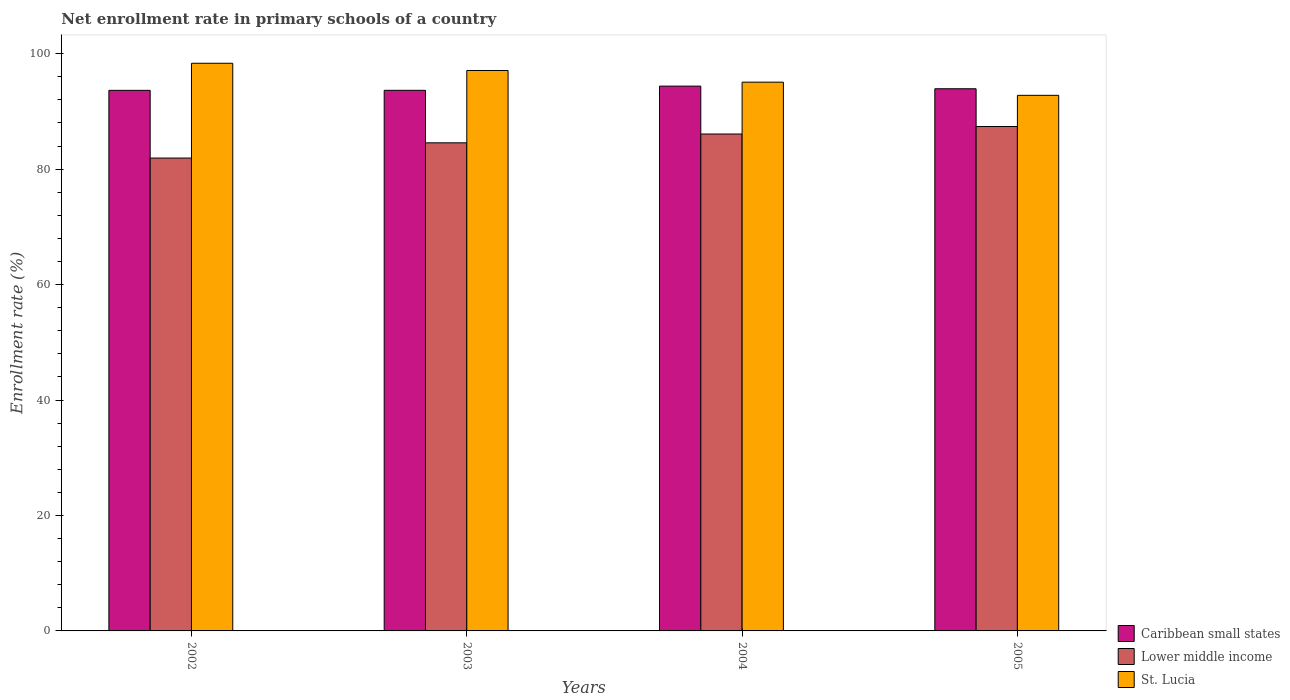Are the number of bars on each tick of the X-axis equal?
Provide a short and direct response. Yes. What is the label of the 1st group of bars from the left?
Ensure brevity in your answer.  2002. What is the enrollment rate in primary schools in St. Lucia in 2005?
Your response must be concise. 92.78. Across all years, what is the maximum enrollment rate in primary schools in Lower middle income?
Provide a short and direct response. 87.38. Across all years, what is the minimum enrollment rate in primary schools in St. Lucia?
Your answer should be very brief. 92.78. In which year was the enrollment rate in primary schools in Lower middle income maximum?
Your answer should be very brief. 2005. In which year was the enrollment rate in primary schools in Lower middle income minimum?
Offer a very short reply. 2002. What is the total enrollment rate in primary schools in Lower middle income in the graph?
Provide a short and direct response. 339.95. What is the difference between the enrollment rate in primary schools in Caribbean small states in 2003 and that in 2004?
Your response must be concise. -0.73. What is the difference between the enrollment rate in primary schools in Caribbean small states in 2005 and the enrollment rate in primary schools in St. Lucia in 2004?
Keep it short and to the point. -1.14. What is the average enrollment rate in primary schools in St. Lucia per year?
Ensure brevity in your answer.  95.82. In the year 2005, what is the difference between the enrollment rate in primary schools in Lower middle income and enrollment rate in primary schools in St. Lucia?
Make the answer very short. -5.4. In how many years, is the enrollment rate in primary schools in Lower middle income greater than 8 %?
Offer a very short reply. 4. What is the ratio of the enrollment rate in primary schools in Lower middle income in 2002 to that in 2003?
Offer a terse response. 0.97. Is the enrollment rate in primary schools in Caribbean small states in 2003 less than that in 2005?
Provide a succinct answer. Yes. What is the difference between the highest and the second highest enrollment rate in primary schools in Caribbean small states?
Provide a succinct answer. 0.46. What is the difference between the highest and the lowest enrollment rate in primary schools in Caribbean small states?
Provide a succinct answer. 0.73. What does the 3rd bar from the left in 2005 represents?
Keep it short and to the point. St. Lucia. What does the 3rd bar from the right in 2002 represents?
Offer a very short reply. Caribbean small states. Is it the case that in every year, the sum of the enrollment rate in primary schools in St. Lucia and enrollment rate in primary schools in Caribbean small states is greater than the enrollment rate in primary schools in Lower middle income?
Provide a succinct answer. Yes. Are all the bars in the graph horizontal?
Your answer should be compact. No. Where does the legend appear in the graph?
Ensure brevity in your answer.  Bottom right. How many legend labels are there?
Your answer should be very brief. 3. How are the legend labels stacked?
Your answer should be compact. Vertical. What is the title of the graph?
Ensure brevity in your answer.  Net enrollment rate in primary schools of a country. What is the label or title of the Y-axis?
Ensure brevity in your answer.  Enrollment rate (%). What is the Enrollment rate (%) in Caribbean small states in 2002?
Your answer should be very brief. 93.65. What is the Enrollment rate (%) of Lower middle income in 2002?
Provide a short and direct response. 81.92. What is the Enrollment rate (%) in St. Lucia in 2002?
Offer a very short reply. 98.34. What is the Enrollment rate (%) in Caribbean small states in 2003?
Offer a terse response. 93.65. What is the Enrollment rate (%) in Lower middle income in 2003?
Provide a succinct answer. 84.56. What is the Enrollment rate (%) in St. Lucia in 2003?
Offer a terse response. 97.09. What is the Enrollment rate (%) of Caribbean small states in 2004?
Offer a terse response. 94.38. What is the Enrollment rate (%) of Lower middle income in 2004?
Offer a terse response. 86.09. What is the Enrollment rate (%) in St. Lucia in 2004?
Keep it short and to the point. 95.07. What is the Enrollment rate (%) of Caribbean small states in 2005?
Make the answer very short. 93.93. What is the Enrollment rate (%) of Lower middle income in 2005?
Give a very brief answer. 87.38. What is the Enrollment rate (%) in St. Lucia in 2005?
Make the answer very short. 92.78. Across all years, what is the maximum Enrollment rate (%) in Caribbean small states?
Make the answer very short. 94.38. Across all years, what is the maximum Enrollment rate (%) in Lower middle income?
Your response must be concise. 87.38. Across all years, what is the maximum Enrollment rate (%) of St. Lucia?
Ensure brevity in your answer.  98.34. Across all years, what is the minimum Enrollment rate (%) in Caribbean small states?
Keep it short and to the point. 93.65. Across all years, what is the minimum Enrollment rate (%) of Lower middle income?
Provide a succinct answer. 81.92. Across all years, what is the minimum Enrollment rate (%) of St. Lucia?
Ensure brevity in your answer.  92.78. What is the total Enrollment rate (%) of Caribbean small states in the graph?
Give a very brief answer. 375.61. What is the total Enrollment rate (%) of Lower middle income in the graph?
Your answer should be compact. 339.95. What is the total Enrollment rate (%) in St. Lucia in the graph?
Offer a very short reply. 383.29. What is the difference between the Enrollment rate (%) of Caribbean small states in 2002 and that in 2003?
Give a very brief answer. -0. What is the difference between the Enrollment rate (%) in Lower middle income in 2002 and that in 2003?
Keep it short and to the point. -2.64. What is the difference between the Enrollment rate (%) of St. Lucia in 2002 and that in 2003?
Your response must be concise. 1.25. What is the difference between the Enrollment rate (%) in Caribbean small states in 2002 and that in 2004?
Offer a terse response. -0.73. What is the difference between the Enrollment rate (%) of Lower middle income in 2002 and that in 2004?
Provide a short and direct response. -4.16. What is the difference between the Enrollment rate (%) in St. Lucia in 2002 and that in 2004?
Provide a succinct answer. 3.27. What is the difference between the Enrollment rate (%) in Caribbean small states in 2002 and that in 2005?
Ensure brevity in your answer.  -0.28. What is the difference between the Enrollment rate (%) of Lower middle income in 2002 and that in 2005?
Keep it short and to the point. -5.46. What is the difference between the Enrollment rate (%) in St. Lucia in 2002 and that in 2005?
Your response must be concise. 5.56. What is the difference between the Enrollment rate (%) of Caribbean small states in 2003 and that in 2004?
Provide a succinct answer. -0.73. What is the difference between the Enrollment rate (%) in Lower middle income in 2003 and that in 2004?
Keep it short and to the point. -1.53. What is the difference between the Enrollment rate (%) in St. Lucia in 2003 and that in 2004?
Keep it short and to the point. 2.02. What is the difference between the Enrollment rate (%) in Caribbean small states in 2003 and that in 2005?
Offer a terse response. -0.27. What is the difference between the Enrollment rate (%) of Lower middle income in 2003 and that in 2005?
Offer a very short reply. -2.82. What is the difference between the Enrollment rate (%) of St. Lucia in 2003 and that in 2005?
Give a very brief answer. 4.31. What is the difference between the Enrollment rate (%) in Caribbean small states in 2004 and that in 2005?
Make the answer very short. 0.46. What is the difference between the Enrollment rate (%) in Lower middle income in 2004 and that in 2005?
Ensure brevity in your answer.  -1.3. What is the difference between the Enrollment rate (%) of St. Lucia in 2004 and that in 2005?
Make the answer very short. 2.28. What is the difference between the Enrollment rate (%) in Caribbean small states in 2002 and the Enrollment rate (%) in Lower middle income in 2003?
Your answer should be very brief. 9.09. What is the difference between the Enrollment rate (%) in Caribbean small states in 2002 and the Enrollment rate (%) in St. Lucia in 2003?
Your response must be concise. -3.44. What is the difference between the Enrollment rate (%) of Lower middle income in 2002 and the Enrollment rate (%) of St. Lucia in 2003?
Offer a terse response. -15.17. What is the difference between the Enrollment rate (%) of Caribbean small states in 2002 and the Enrollment rate (%) of Lower middle income in 2004?
Ensure brevity in your answer.  7.56. What is the difference between the Enrollment rate (%) of Caribbean small states in 2002 and the Enrollment rate (%) of St. Lucia in 2004?
Provide a succinct answer. -1.42. What is the difference between the Enrollment rate (%) of Lower middle income in 2002 and the Enrollment rate (%) of St. Lucia in 2004?
Your answer should be compact. -13.15. What is the difference between the Enrollment rate (%) in Caribbean small states in 2002 and the Enrollment rate (%) in Lower middle income in 2005?
Give a very brief answer. 6.26. What is the difference between the Enrollment rate (%) in Caribbean small states in 2002 and the Enrollment rate (%) in St. Lucia in 2005?
Give a very brief answer. 0.86. What is the difference between the Enrollment rate (%) of Lower middle income in 2002 and the Enrollment rate (%) of St. Lucia in 2005?
Offer a terse response. -10.86. What is the difference between the Enrollment rate (%) in Caribbean small states in 2003 and the Enrollment rate (%) in Lower middle income in 2004?
Make the answer very short. 7.57. What is the difference between the Enrollment rate (%) of Caribbean small states in 2003 and the Enrollment rate (%) of St. Lucia in 2004?
Offer a very short reply. -1.41. What is the difference between the Enrollment rate (%) of Lower middle income in 2003 and the Enrollment rate (%) of St. Lucia in 2004?
Provide a succinct answer. -10.51. What is the difference between the Enrollment rate (%) of Caribbean small states in 2003 and the Enrollment rate (%) of Lower middle income in 2005?
Your answer should be very brief. 6.27. What is the difference between the Enrollment rate (%) in Caribbean small states in 2003 and the Enrollment rate (%) in St. Lucia in 2005?
Provide a short and direct response. 0.87. What is the difference between the Enrollment rate (%) of Lower middle income in 2003 and the Enrollment rate (%) of St. Lucia in 2005?
Ensure brevity in your answer.  -8.22. What is the difference between the Enrollment rate (%) of Caribbean small states in 2004 and the Enrollment rate (%) of Lower middle income in 2005?
Offer a terse response. 7. What is the difference between the Enrollment rate (%) in Caribbean small states in 2004 and the Enrollment rate (%) in St. Lucia in 2005?
Give a very brief answer. 1.6. What is the difference between the Enrollment rate (%) in Lower middle income in 2004 and the Enrollment rate (%) in St. Lucia in 2005?
Offer a terse response. -6.7. What is the average Enrollment rate (%) in Caribbean small states per year?
Provide a short and direct response. 93.9. What is the average Enrollment rate (%) in Lower middle income per year?
Your answer should be compact. 84.99. What is the average Enrollment rate (%) of St. Lucia per year?
Your answer should be compact. 95.82. In the year 2002, what is the difference between the Enrollment rate (%) of Caribbean small states and Enrollment rate (%) of Lower middle income?
Your response must be concise. 11.73. In the year 2002, what is the difference between the Enrollment rate (%) in Caribbean small states and Enrollment rate (%) in St. Lucia?
Provide a succinct answer. -4.69. In the year 2002, what is the difference between the Enrollment rate (%) in Lower middle income and Enrollment rate (%) in St. Lucia?
Your response must be concise. -16.42. In the year 2003, what is the difference between the Enrollment rate (%) in Caribbean small states and Enrollment rate (%) in Lower middle income?
Provide a short and direct response. 9.09. In the year 2003, what is the difference between the Enrollment rate (%) in Caribbean small states and Enrollment rate (%) in St. Lucia?
Provide a succinct answer. -3.44. In the year 2003, what is the difference between the Enrollment rate (%) of Lower middle income and Enrollment rate (%) of St. Lucia?
Offer a terse response. -12.53. In the year 2004, what is the difference between the Enrollment rate (%) in Caribbean small states and Enrollment rate (%) in Lower middle income?
Offer a terse response. 8.3. In the year 2004, what is the difference between the Enrollment rate (%) in Caribbean small states and Enrollment rate (%) in St. Lucia?
Ensure brevity in your answer.  -0.69. In the year 2004, what is the difference between the Enrollment rate (%) of Lower middle income and Enrollment rate (%) of St. Lucia?
Make the answer very short. -8.98. In the year 2005, what is the difference between the Enrollment rate (%) in Caribbean small states and Enrollment rate (%) in Lower middle income?
Provide a succinct answer. 6.54. In the year 2005, what is the difference between the Enrollment rate (%) of Caribbean small states and Enrollment rate (%) of St. Lucia?
Provide a succinct answer. 1.14. In the year 2005, what is the difference between the Enrollment rate (%) of Lower middle income and Enrollment rate (%) of St. Lucia?
Keep it short and to the point. -5.4. What is the ratio of the Enrollment rate (%) of Lower middle income in 2002 to that in 2003?
Offer a very short reply. 0.97. What is the ratio of the Enrollment rate (%) in St. Lucia in 2002 to that in 2003?
Provide a succinct answer. 1.01. What is the ratio of the Enrollment rate (%) of Caribbean small states in 2002 to that in 2004?
Give a very brief answer. 0.99. What is the ratio of the Enrollment rate (%) in Lower middle income in 2002 to that in 2004?
Your answer should be compact. 0.95. What is the ratio of the Enrollment rate (%) in St. Lucia in 2002 to that in 2004?
Provide a short and direct response. 1.03. What is the ratio of the Enrollment rate (%) of Lower middle income in 2002 to that in 2005?
Your answer should be compact. 0.94. What is the ratio of the Enrollment rate (%) of St. Lucia in 2002 to that in 2005?
Keep it short and to the point. 1.06. What is the ratio of the Enrollment rate (%) in Caribbean small states in 2003 to that in 2004?
Provide a succinct answer. 0.99. What is the ratio of the Enrollment rate (%) of Lower middle income in 2003 to that in 2004?
Your answer should be compact. 0.98. What is the ratio of the Enrollment rate (%) in St. Lucia in 2003 to that in 2004?
Your answer should be very brief. 1.02. What is the ratio of the Enrollment rate (%) in Lower middle income in 2003 to that in 2005?
Your response must be concise. 0.97. What is the ratio of the Enrollment rate (%) in St. Lucia in 2003 to that in 2005?
Offer a very short reply. 1.05. What is the ratio of the Enrollment rate (%) in Caribbean small states in 2004 to that in 2005?
Give a very brief answer. 1. What is the ratio of the Enrollment rate (%) in Lower middle income in 2004 to that in 2005?
Your answer should be compact. 0.99. What is the ratio of the Enrollment rate (%) in St. Lucia in 2004 to that in 2005?
Make the answer very short. 1.02. What is the difference between the highest and the second highest Enrollment rate (%) of Caribbean small states?
Make the answer very short. 0.46. What is the difference between the highest and the second highest Enrollment rate (%) in Lower middle income?
Offer a terse response. 1.3. What is the difference between the highest and the second highest Enrollment rate (%) in St. Lucia?
Make the answer very short. 1.25. What is the difference between the highest and the lowest Enrollment rate (%) of Caribbean small states?
Provide a succinct answer. 0.73. What is the difference between the highest and the lowest Enrollment rate (%) of Lower middle income?
Provide a short and direct response. 5.46. What is the difference between the highest and the lowest Enrollment rate (%) of St. Lucia?
Ensure brevity in your answer.  5.56. 